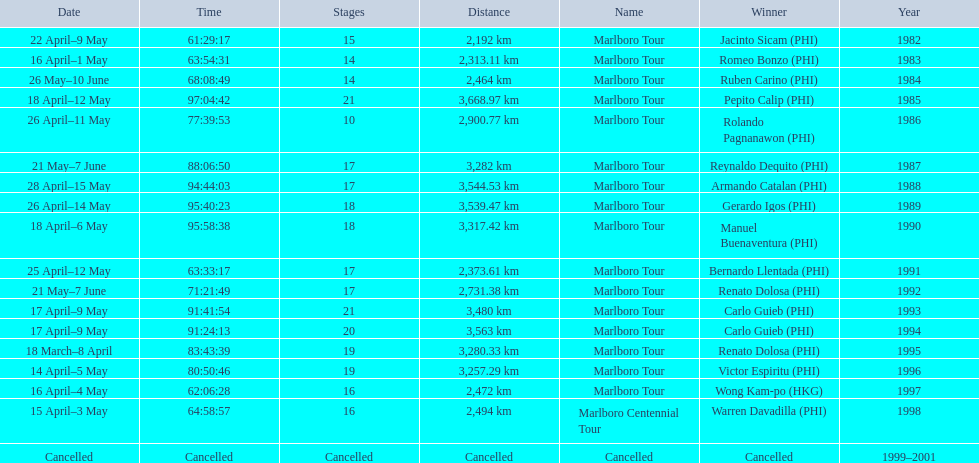Which year did warren davdilla (w.d.) appear? 1998. What tour did w.d. complete? Marlboro Centennial Tour. What is the time recorded in the same row as w.d.? 64:58:57. 